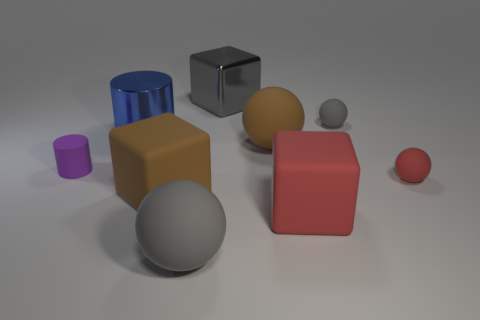Subtract all large rubber blocks. How many blocks are left? 1 Add 1 blue cylinders. How many objects exist? 10 Subtract all brown blocks. How many blocks are left? 2 Subtract all spheres. How many objects are left? 5 Subtract 1 spheres. How many spheres are left? 3 Subtract all yellow cubes. How many brown balls are left? 1 Add 3 matte spheres. How many matte spheres exist? 7 Subtract 1 blue cylinders. How many objects are left? 8 Subtract all yellow spheres. Subtract all brown cubes. How many spheres are left? 4 Subtract all tiny brown shiny cylinders. Subtract all big blue metal cylinders. How many objects are left? 8 